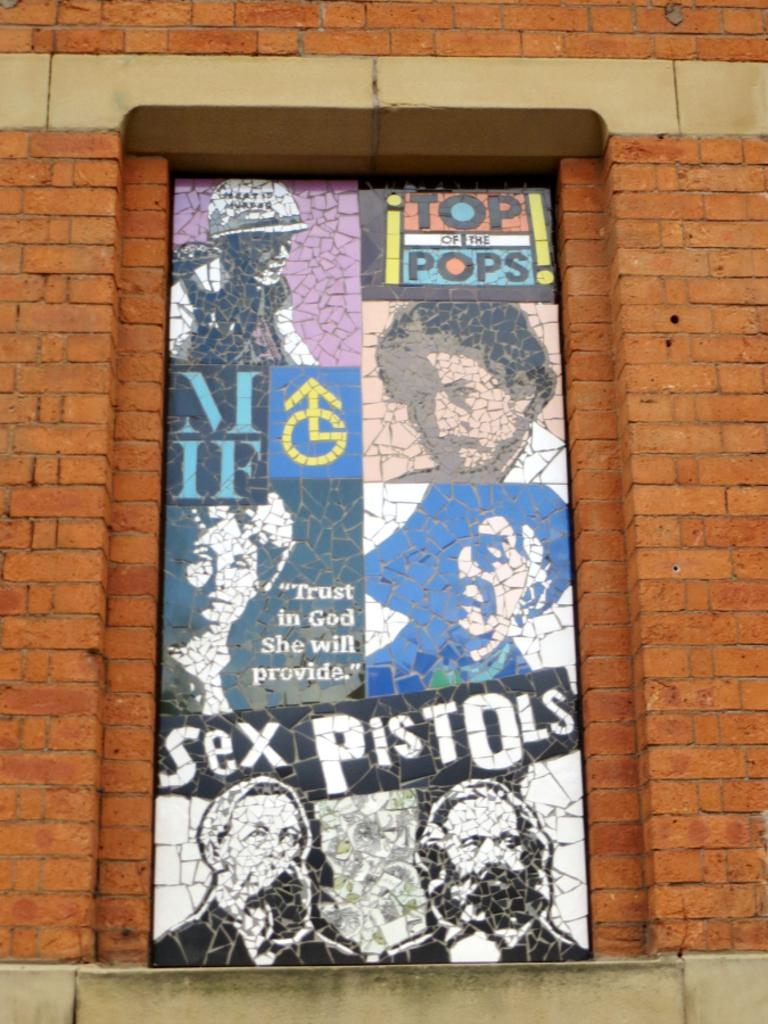<image>
Create a compact narrative representing the image presented. The top of the pops billboard with celebrity faces 